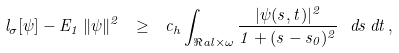<formula> <loc_0><loc_0><loc_500><loc_500>l _ { \sigma } [ \psi ] - E _ { 1 } \, \| \psi \| ^ { 2 } \ \geq \ c _ { h } \int _ { \Re a l \times \omega } \frac { | \psi ( s , t ) | ^ { 2 } } { 1 + ( s - s _ { 0 } ) ^ { 2 } } \ d s \, d t \, ,</formula> 